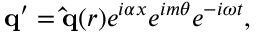Convert formula to latex. <formula><loc_0><loc_0><loc_500><loc_500>q ^ { \prime } = \hat { q } ( r ) e ^ { i \alpha x } e ^ { i m \theta } e ^ { - i \omega t } ,</formula> 